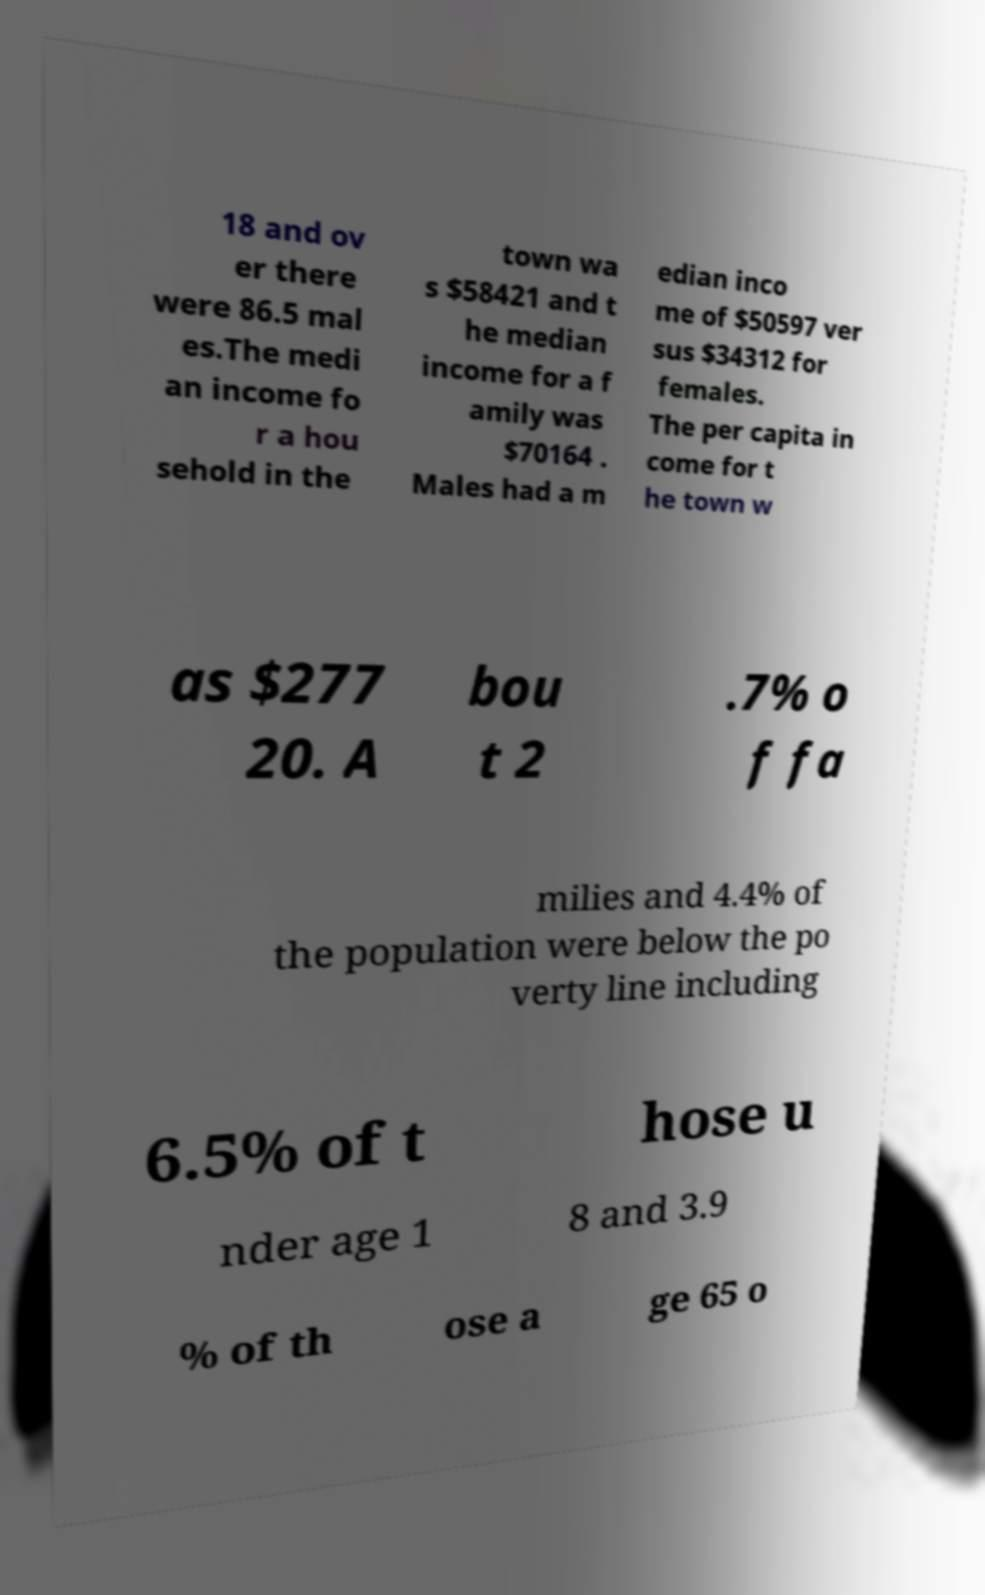Can you read and provide the text displayed in the image?This photo seems to have some interesting text. Can you extract and type it out for me? 18 and ov er there were 86.5 mal es.The medi an income fo r a hou sehold in the town wa s $58421 and t he median income for a f amily was $70164 . Males had a m edian inco me of $50597 ver sus $34312 for females. The per capita in come for t he town w as $277 20. A bou t 2 .7% o f fa milies and 4.4% of the population were below the po verty line including 6.5% of t hose u nder age 1 8 and 3.9 % of th ose a ge 65 o 